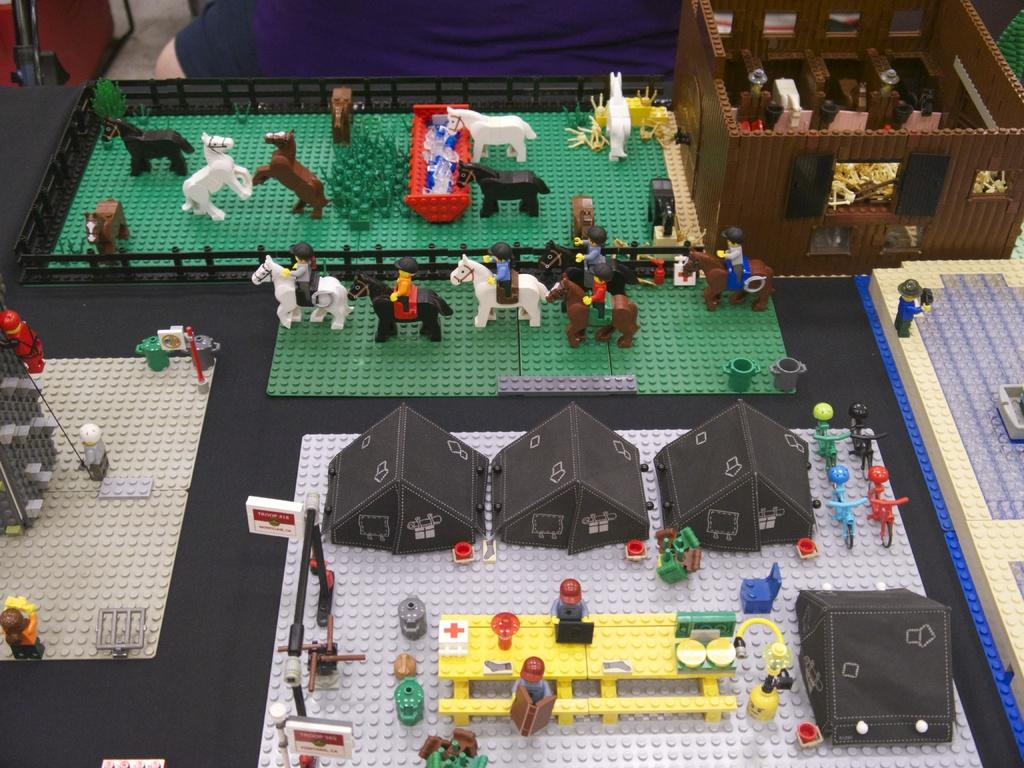What is on the board in the image? There are toys on the board in the image. Can you describe the background of the image? There is a person and a stand visible in the background of the image. What type of system is being used by the cattle in the image? There are no cattle present in the image, so it is not possible to determine what type of system they might be using. 